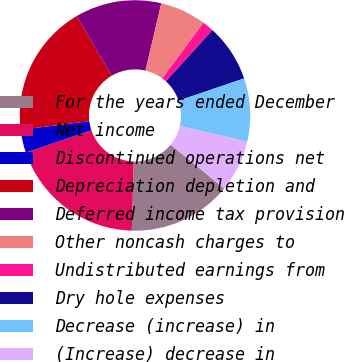<chart> <loc_0><loc_0><loc_500><loc_500><pie_chart><fcel>For the years ended December<fcel>Net income<fcel>Discontinued operations net<fcel>Depreciation depletion and<fcel>Deferred income tax provision<fcel>Other noncash charges to<fcel>Undistributed earnings from<fcel>Dry hole expenses<fcel>Decrease (increase) in<fcel>(Increase) decrease in<nl><fcel>14.52%<fcel>19.35%<fcel>3.23%<fcel>18.55%<fcel>12.1%<fcel>6.45%<fcel>1.61%<fcel>8.06%<fcel>8.87%<fcel>7.26%<nl></chart> 